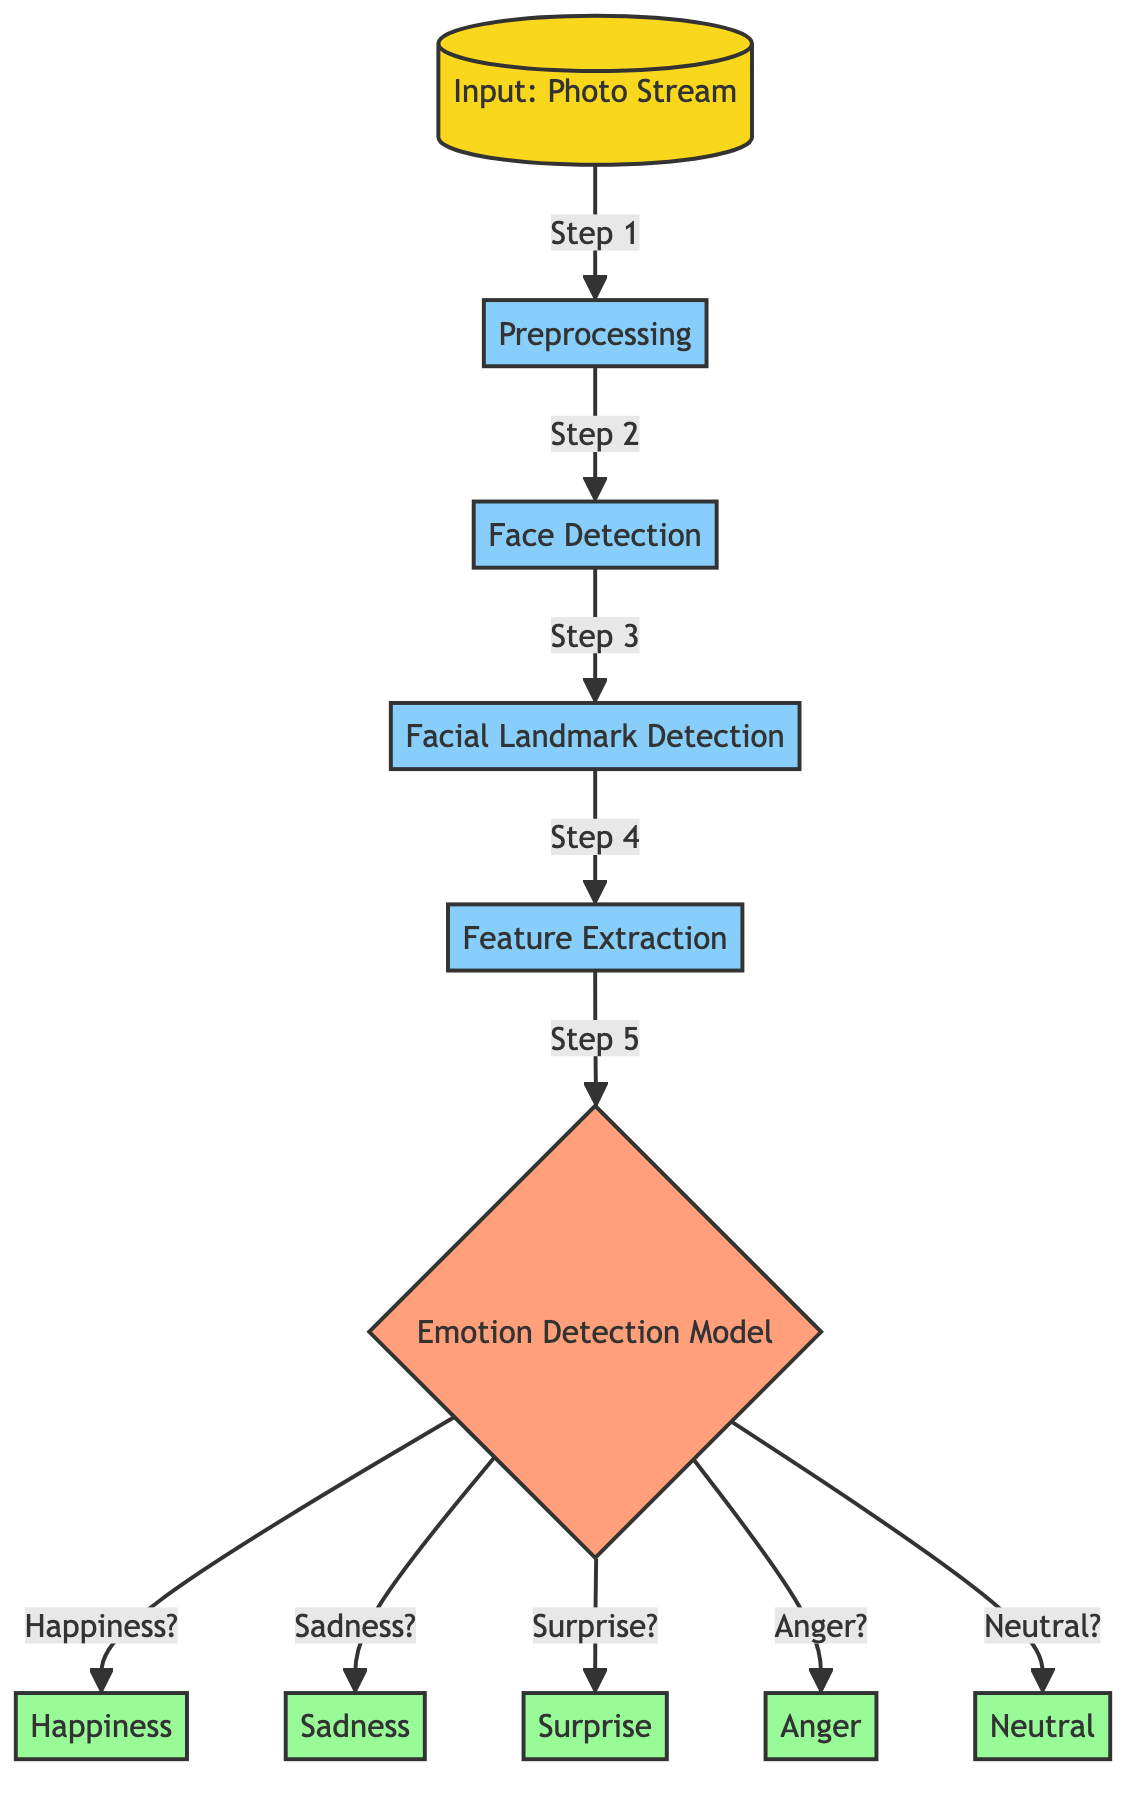What is the first step in the process? The first step in the process, as indicated in the diagram, is "Preprocessing", which follows after receiving the photo stream input.
Answer: Preprocessing How many output emotions are there? The diagram indicates five output emotions: Happiness, Sadness, Surprise, Anger, and Neutral, which are the results of the emotion detection model.
Answer: Five What follows "Face Detection" in the flow? After "Face Detection", the next step in the flow is "Facial Landmark Detection", continuing the processing sequence.
Answer: Facial Landmark Detection What is the final output of the emotion detection model if it detects happiness? If the emotion detection model detects happiness, the output would be "Happiness", as shown at the end of the decision node paths.
Answer: Happiness What type of nodes are "Happiness," "Sadness," "Surprise," "Anger," and "Neutral"? These nodes represent outputs of the emotion detection model, categorized as output nodes in the diagram.
Answer: Output nodes How many processing steps are there in total? There are five processing steps depicted in the diagram: Preprocessing, Face Detection, Facial Landmark Detection, Feature Extraction, and the Emotion Detection Model itself, making a total of five.
Answer: Five What decision must be made after feature extraction? After feature extraction, the decision that needs to be made is regarding the specific emotion to classify from the input, represented in the decision node.
Answer: Emotion classification Which step occurs directly after preprocessing? Directly after preprocessing, the "Face Detection" step occurs, as shown in the diagram's sequential order.
Answer: Face Detection 